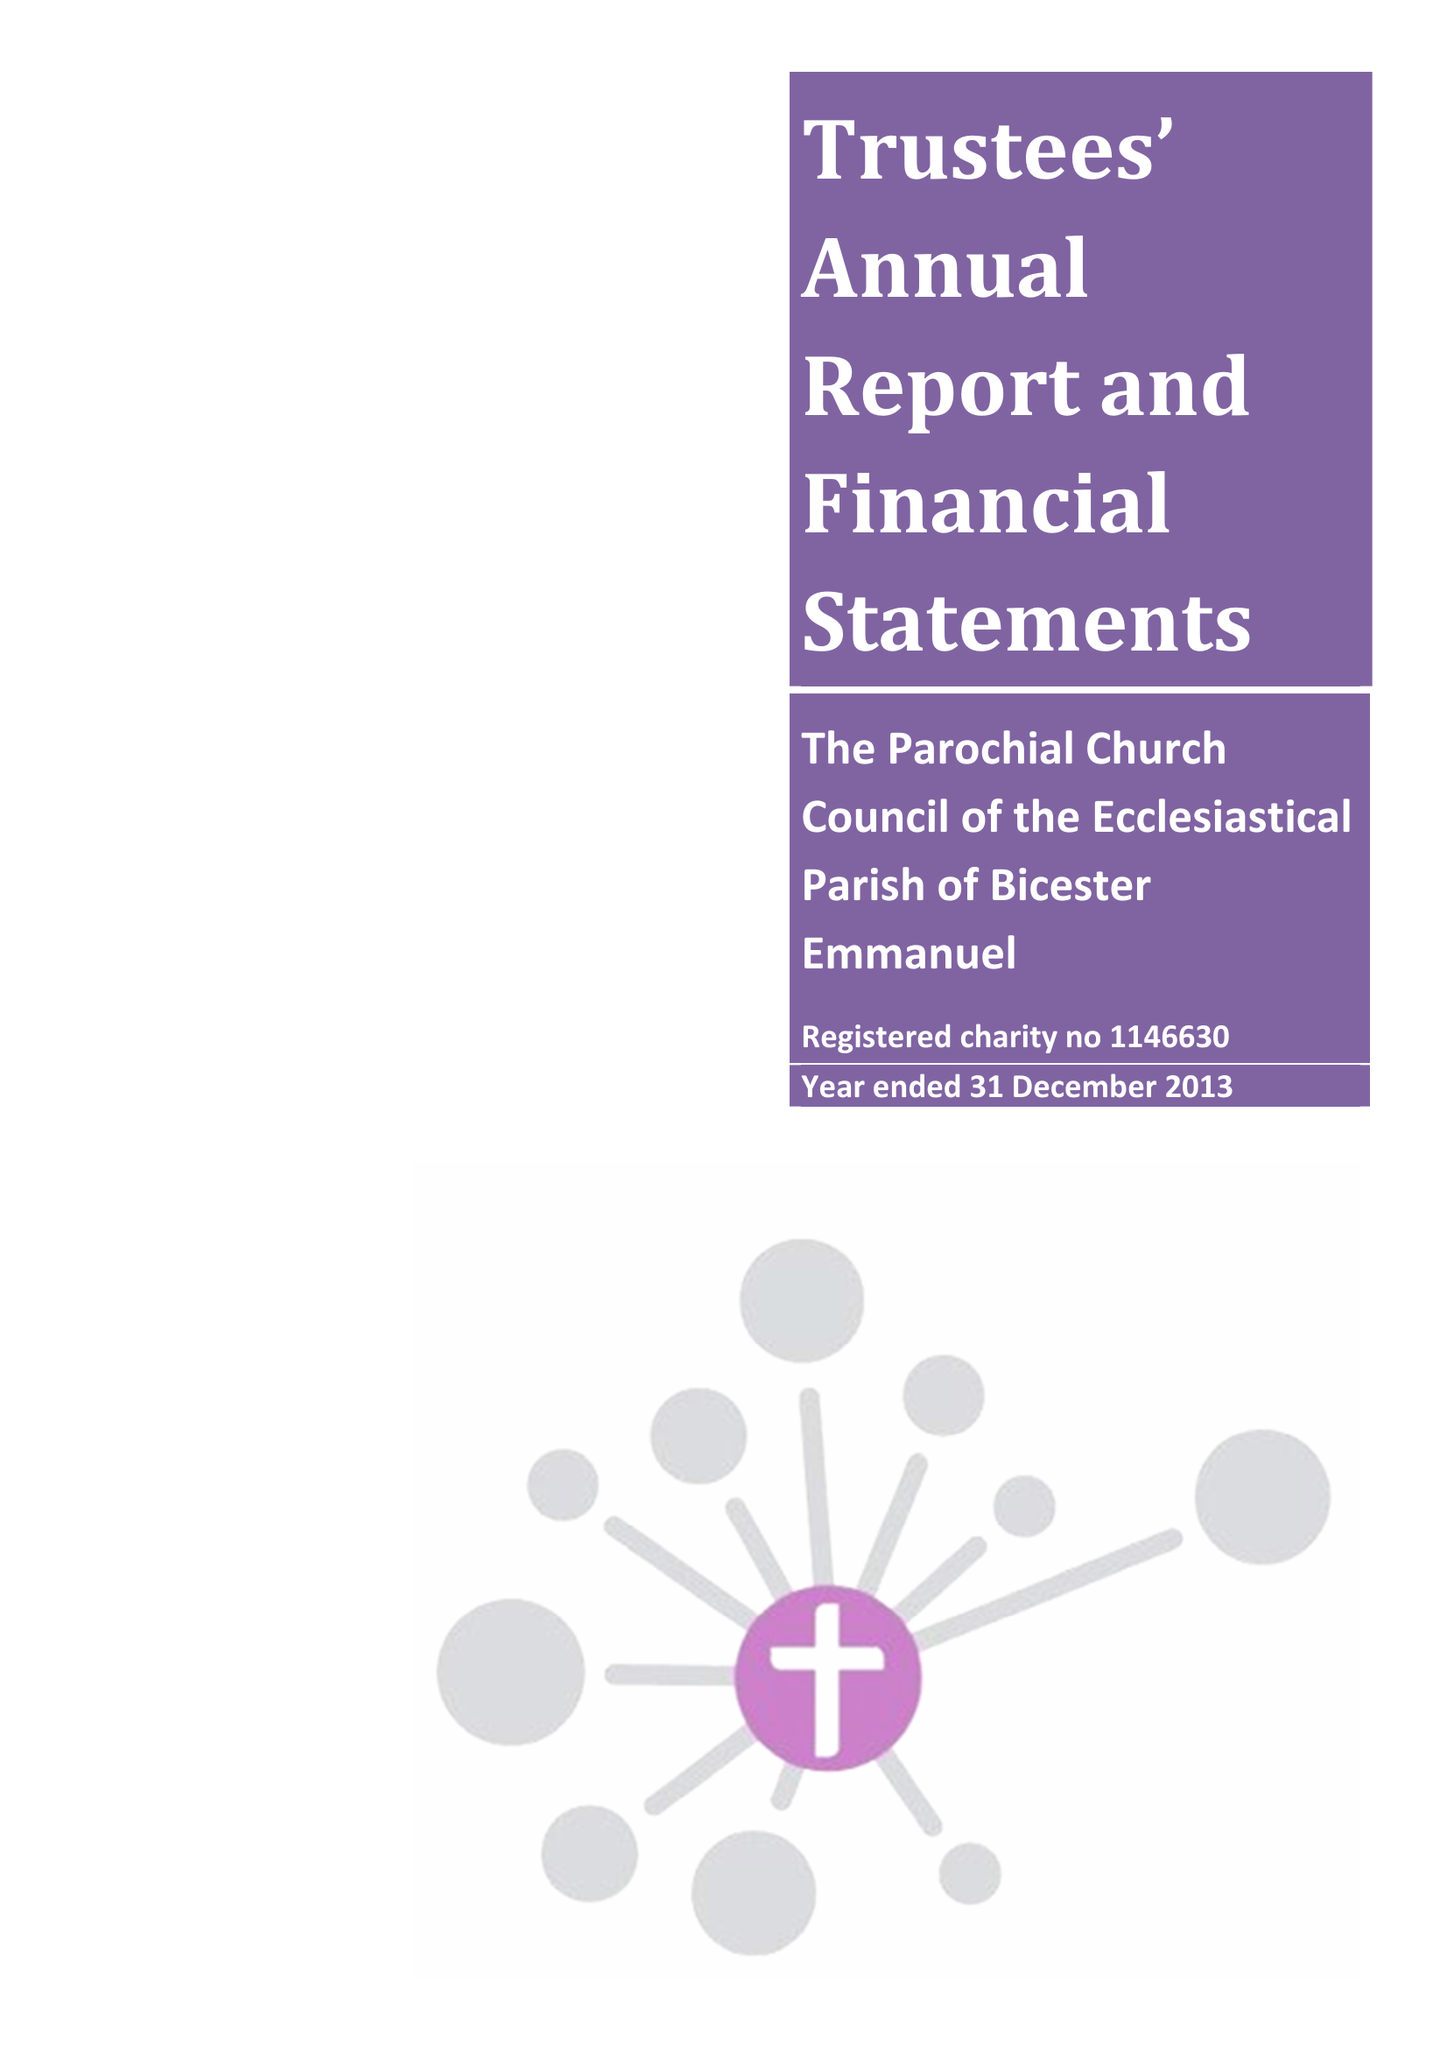What is the value for the report_date?
Answer the question using a single word or phrase. 2013-12-31 